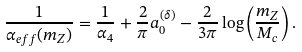<formula> <loc_0><loc_0><loc_500><loc_500>\frac { 1 } { \alpha _ { e f f } ( m _ { Z } ) } = \frac { 1 } { \alpha _ { 4 } } + \frac { 2 } { \pi } a _ { 0 } ^ { ( \delta ) } - \frac { 2 } { 3 \pi } \log \left ( \frac { m _ { Z } } { M _ { c } } \right ) .</formula> 